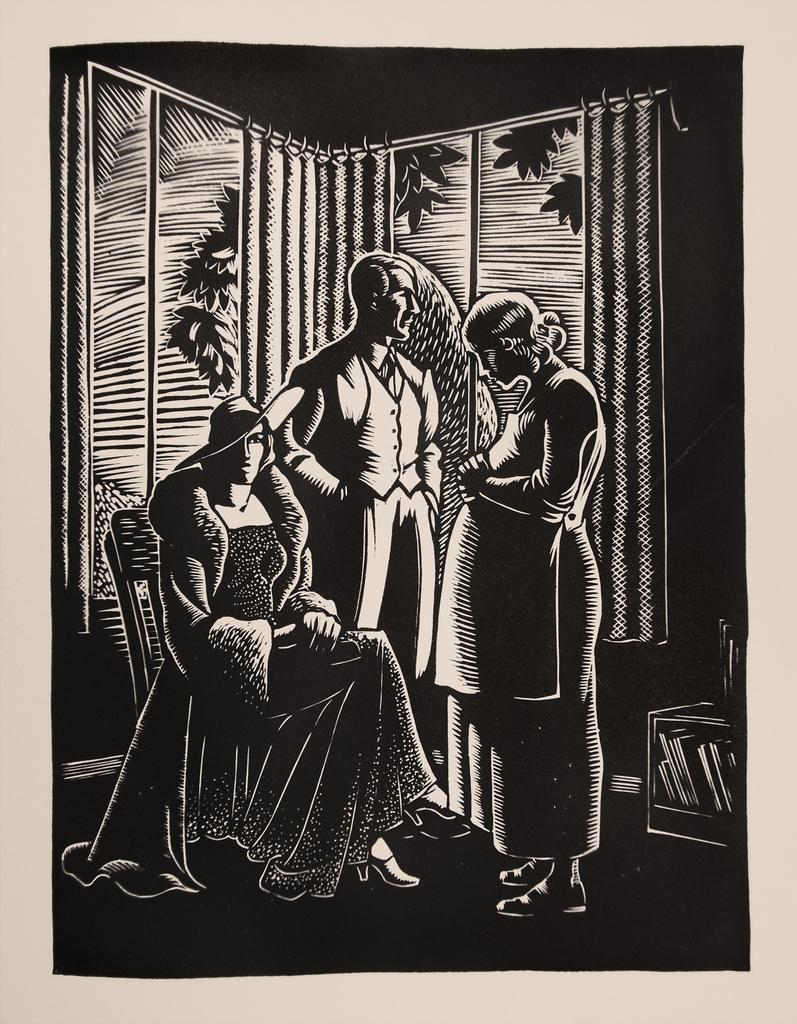How many people are in the image? There are three persons in the image. What are the positions of the people in the image? One person is sitting on a chair, and two persons are standing. What is the person sitting on the chair wearing? The person sitting on the chair is wearing a hat. What can be seen on the stand in the image? There is a stand with books in the image. What is visible in the background of the image? There are curtains in the background of the image. What type of clover is being used as bait in the image? There is no clover or bait present in the image. What kind of powder is being applied to the books on the stand? There is no powder visible on the books in the image. 